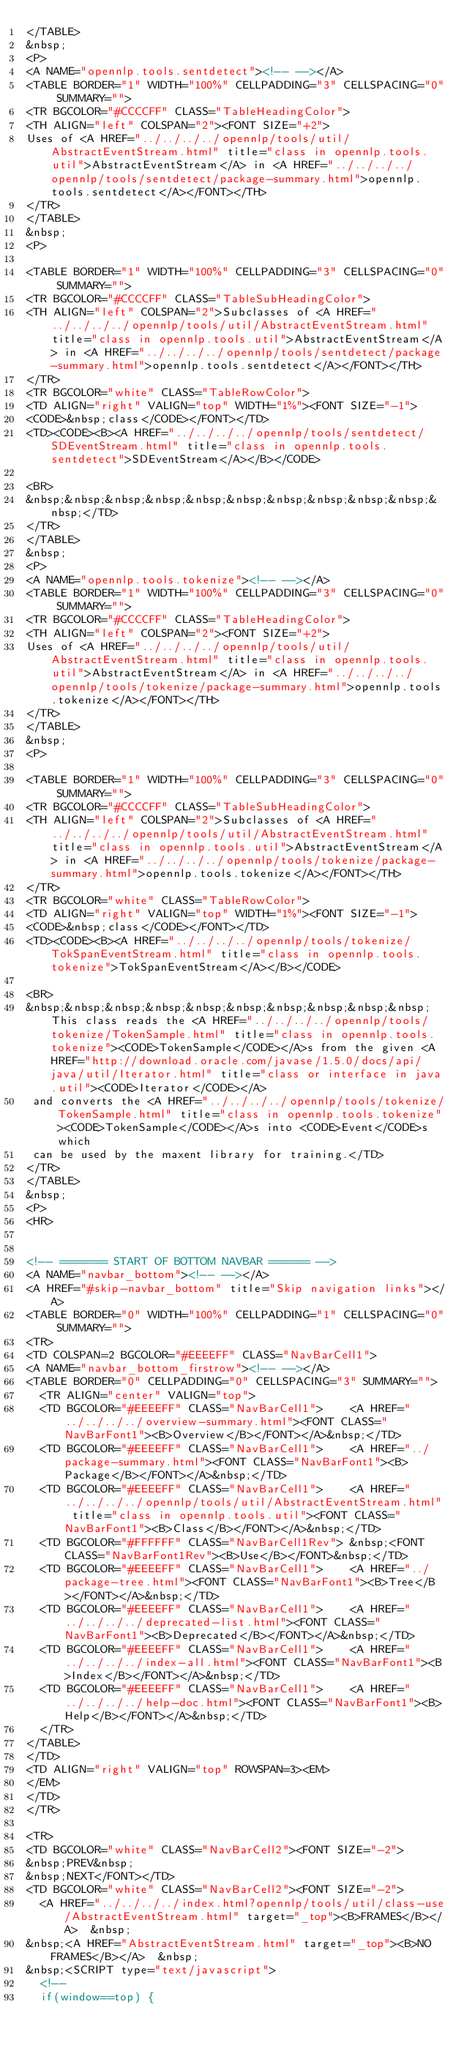Convert code to text. <code><loc_0><loc_0><loc_500><loc_500><_HTML_></TABLE>
&nbsp;
<P>
<A NAME="opennlp.tools.sentdetect"><!-- --></A>
<TABLE BORDER="1" WIDTH="100%" CELLPADDING="3" CELLSPACING="0" SUMMARY="">
<TR BGCOLOR="#CCCCFF" CLASS="TableHeadingColor">
<TH ALIGN="left" COLSPAN="2"><FONT SIZE="+2">
Uses of <A HREF="../../../../opennlp/tools/util/AbstractEventStream.html" title="class in opennlp.tools.util">AbstractEventStream</A> in <A HREF="../../../../opennlp/tools/sentdetect/package-summary.html">opennlp.tools.sentdetect</A></FONT></TH>
</TR>
</TABLE>
&nbsp;
<P>

<TABLE BORDER="1" WIDTH="100%" CELLPADDING="3" CELLSPACING="0" SUMMARY="">
<TR BGCOLOR="#CCCCFF" CLASS="TableSubHeadingColor">
<TH ALIGN="left" COLSPAN="2">Subclasses of <A HREF="../../../../opennlp/tools/util/AbstractEventStream.html" title="class in opennlp.tools.util">AbstractEventStream</A> in <A HREF="../../../../opennlp/tools/sentdetect/package-summary.html">opennlp.tools.sentdetect</A></FONT></TH>
</TR>
<TR BGCOLOR="white" CLASS="TableRowColor">
<TD ALIGN="right" VALIGN="top" WIDTH="1%"><FONT SIZE="-1">
<CODE>&nbsp;class</CODE></FONT></TD>
<TD><CODE><B><A HREF="../../../../opennlp/tools/sentdetect/SDEventStream.html" title="class in opennlp.tools.sentdetect">SDEventStream</A></B></CODE>

<BR>
&nbsp;&nbsp;&nbsp;&nbsp;&nbsp;&nbsp;&nbsp;&nbsp;&nbsp;&nbsp;&nbsp;</TD>
</TR>
</TABLE>
&nbsp;
<P>
<A NAME="opennlp.tools.tokenize"><!-- --></A>
<TABLE BORDER="1" WIDTH="100%" CELLPADDING="3" CELLSPACING="0" SUMMARY="">
<TR BGCOLOR="#CCCCFF" CLASS="TableHeadingColor">
<TH ALIGN="left" COLSPAN="2"><FONT SIZE="+2">
Uses of <A HREF="../../../../opennlp/tools/util/AbstractEventStream.html" title="class in opennlp.tools.util">AbstractEventStream</A> in <A HREF="../../../../opennlp/tools/tokenize/package-summary.html">opennlp.tools.tokenize</A></FONT></TH>
</TR>
</TABLE>
&nbsp;
<P>

<TABLE BORDER="1" WIDTH="100%" CELLPADDING="3" CELLSPACING="0" SUMMARY="">
<TR BGCOLOR="#CCCCFF" CLASS="TableSubHeadingColor">
<TH ALIGN="left" COLSPAN="2">Subclasses of <A HREF="../../../../opennlp/tools/util/AbstractEventStream.html" title="class in opennlp.tools.util">AbstractEventStream</A> in <A HREF="../../../../opennlp/tools/tokenize/package-summary.html">opennlp.tools.tokenize</A></FONT></TH>
</TR>
<TR BGCOLOR="white" CLASS="TableRowColor">
<TD ALIGN="right" VALIGN="top" WIDTH="1%"><FONT SIZE="-1">
<CODE>&nbsp;class</CODE></FONT></TD>
<TD><CODE><B><A HREF="../../../../opennlp/tools/tokenize/TokSpanEventStream.html" title="class in opennlp.tools.tokenize">TokSpanEventStream</A></B></CODE>

<BR>
&nbsp;&nbsp;&nbsp;&nbsp;&nbsp;&nbsp;&nbsp;&nbsp;&nbsp;&nbsp;This class reads the <A HREF="../../../../opennlp/tools/tokenize/TokenSample.html" title="class in opennlp.tools.tokenize"><CODE>TokenSample</CODE></A>s from the given <A HREF="http://download.oracle.com/javase/1.5.0/docs/api/java/util/Iterator.html" title="class or interface in java.util"><CODE>Iterator</CODE></A>
 and converts the <A HREF="../../../../opennlp/tools/tokenize/TokenSample.html" title="class in opennlp.tools.tokenize"><CODE>TokenSample</CODE></A>s into <CODE>Event</CODE>s which
 can be used by the maxent library for training.</TD>
</TR>
</TABLE>
&nbsp;
<P>
<HR>


<!-- ======= START OF BOTTOM NAVBAR ====== -->
<A NAME="navbar_bottom"><!-- --></A>
<A HREF="#skip-navbar_bottom" title="Skip navigation links"></A>
<TABLE BORDER="0" WIDTH="100%" CELLPADDING="1" CELLSPACING="0" SUMMARY="">
<TR>
<TD COLSPAN=2 BGCOLOR="#EEEEFF" CLASS="NavBarCell1">
<A NAME="navbar_bottom_firstrow"><!-- --></A>
<TABLE BORDER="0" CELLPADDING="0" CELLSPACING="3" SUMMARY="">
  <TR ALIGN="center" VALIGN="top">
  <TD BGCOLOR="#EEEEFF" CLASS="NavBarCell1">    <A HREF="../../../../overview-summary.html"><FONT CLASS="NavBarFont1"><B>Overview</B></FONT></A>&nbsp;</TD>
  <TD BGCOLOR="#EEEEFF" CLASS="NavBarCell1">    <A HREF="../package-summary.html"><FONT CLASS="NavBarFont1"><B>Package</B></FONT></A>&nbsp;</TD>
  <TD BGCOLOR="#EEEEFF" CLASS="NavBarCell1">    <A HREF="../../../../opennlp/tools/util/AbstractEventStream.html" title="class in opennlp.tools.util"><FONT CLASS="NavBarFont1"><B>Class</B></FONT></A>&nbsp;</TD>
  <TD BGCOLOR="#FFFFFF" CLASS="NavBarCell1Rev"> &nbsp;<FONT CLASS="NavBarFont1Rev"><B>Use</B></FONT>&nbsp;</TD>
  <TD BGCOLOR="#EEEEFF" CLASS="NavBarCell1">    <A HREF="../package-tree.html"><FONT CLASS="NavBarFont1"><B>Tree</B></FONT></A>&nbsp;</TD>
  <TD BGCOLOR="#EEEEFF" CLASS="NavBarCell1">    <A HREF="../../../../deprecated-list.html"><FONT CLASS="NavBarFont1"><B>Deprecated</B></FONT></A>&nbsp;</TD>
  <TD BGCOLOR="#EEEEFF" CLASS="NavBarCell1">    <A HREF="../../../../index-all.html"><FONT CLASS="NavBarFont1"><B>Index</B></FONT></A>&nbsp;</TD>
  <TD BGCOLOR="#EEEEFF" CLASS="NavBarCell1">    <A HREF="../../../../help-doc.html"><FONT CLASS="NavBarFont1"><B>Help</B></FONT></A>&nbsp;</TD>
  </TR>
</TABLE>
</TD>
<TD ALIGN="right" VALIGN="top" ROWSPAN=3><EM>
</EM>
</TD>
</TR>

<TR>
<TD BGCOLOR="white" CLASS="NavBarCell2"><FONT SIZE="-2">
&nbsp;PREV&nbsp;
&nbsp;NEXT</FONT></TD>
<TD BGCOLOR="white" CLASS="NavBarCell2"><FONT SIZE="-2">
  <A HREF="../../../../index.html?opennlp/tools/util/class-use/AbstractEventStream.html" target="_top"><B>FRAMES</B></A>  &nbsp;
&nbsp;<A HREF="AbstractEventStream.html" target="_top"><B>NO FRAMES</B></A>  &nbsp;
&nbsp;<SCRIPT type="text/javascript">
  <!--
  if(window==top) {</code> 